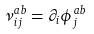Convert formula to latex. <formula><loc_0><loc_0><loc_500><loc_500>\nu _ { i j } ^ { a b } = \partial _ { i } \phi _ { j } ^ { a b }</formula> 